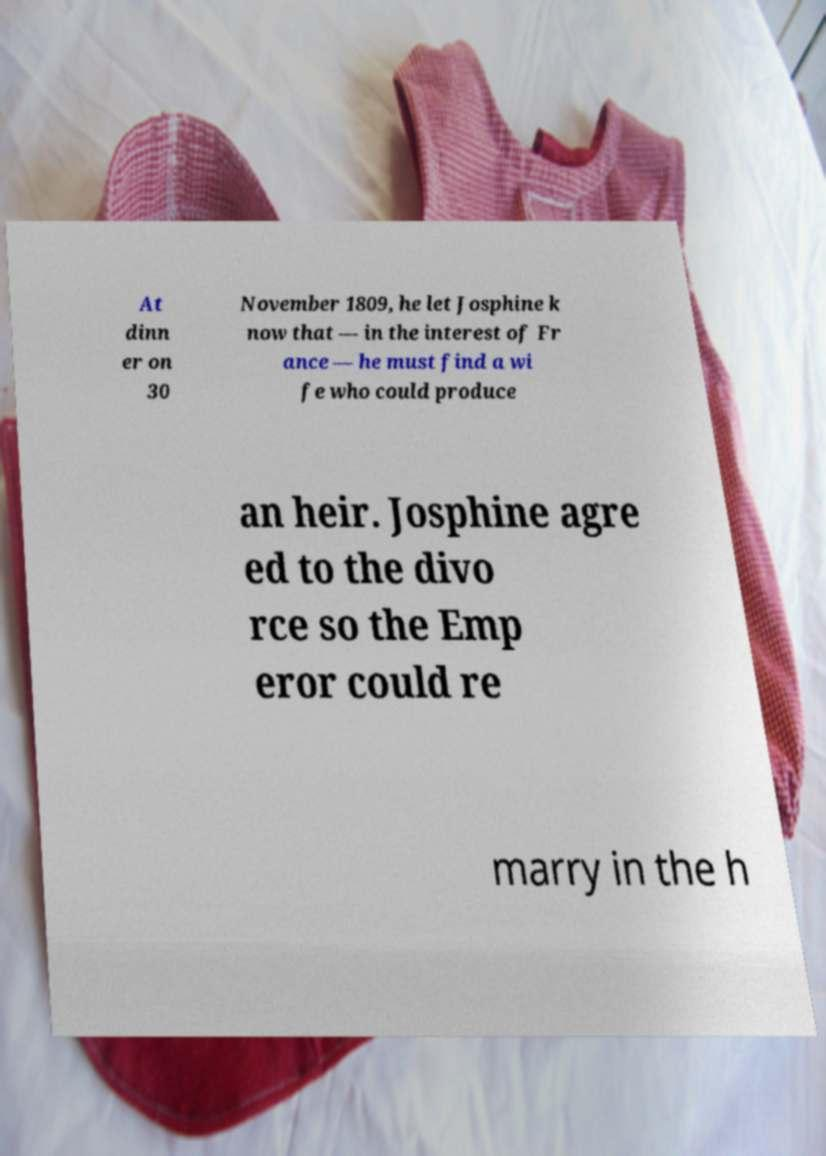What messages or text are displayed in this image? I need them in a readable, typed format. At dinn er on 30 November 1809, he let Josphine k now that — in the interest of Fr ance — he must find a wi fe who could produce an heir. Josphine agre ed to the divo rce so the Emp eror could re marry in the h 